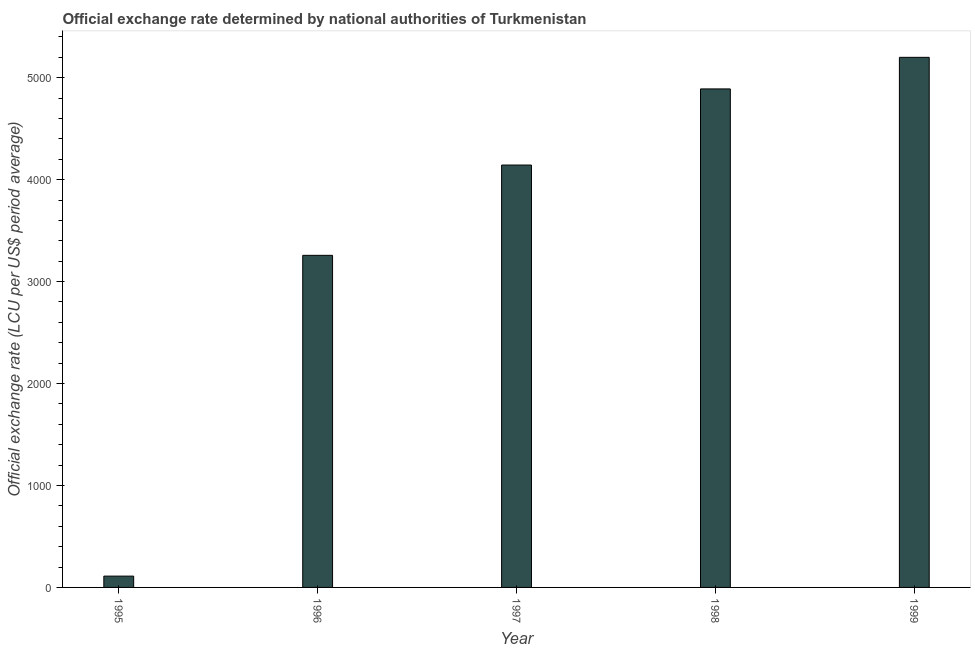Does the graph contain grids?
Offer a terse response. No. What is the title of the graph?
Ensure brevity in your answer.  Official exchange rate determined by national authorities of Turkmenistan. What is the label or title of the Y-axis?
Give a very brief answer. Official exchange rate (LCU per US$ period average). What is the official exchange rate in 1998?
Give a very brief answer. 4890.17. Across all years, what is the maximum official exchange rate?
Provide a succinct answer. 5200. Across all years, what is the minimum official exchange rate?
Your answer should be compact. 110.92. In which year was the official exchange rate maximum?
Your answer should be very brief. 1999. In which year was the official exchange rate minimum?
Offer a terse response. 1995. What is the sum of the official exchange rate?
Your response must be concise. 1.76e+04. What is the difference between the official exchange rate in 1998 and 1999?
Give a very brief answer. -309.83. What is the average official exchange rate per year?
Your response must be concise. 3520.43. What is the median official exchange rate?
Make the answer very short. 4143.42. In how many years, is the official exchange rate greater than 1800 ?
Keep it short and to the point. 4. Do a majority of the years between 1995 and 1996 (inclusive) have official exchange rate greater than 5200 ?
Offer a very short reply. No. What is the ratio of the official exchange rate in 1995 to that in 1999?
Make the answer very short. 0.02. What is the difference between the highest and the second highest official exchange rate?
Give a very brief answer. 309.83. Is the sum of the official exchange rate in 1998 and 1999 greater than the maximum official exchange rate across all years?
Your answer should be compact. Yes. What is the difference between the highest and the lowest official exchange rate?
Ensure brevity in your answer.  5089.08. In how many years, is the official exchange rate greater than the average official exchange rate taken over all years?
Make the answer very short. 3. How many years are there in the graph?
Provide a succinct answer. 5. What is the difference between two consecutive major ticks on the Y-axis?
Offer a terse response. 1000. What is the Official exchange rate (LCU per US$ period average) in 1995?
Make the answer very short. 110.92. What is the Official exchange rate (LCU per US$ period average) of 1996?
Ensure brevity in your answer.  3257.67. What is the Official exchange rate (LCU per US$ period average) of 1997?
Make the answer very short. 4143.42. What is the Official exchange rate (LCU per US$ period average) in 1998?
Ensure brevity in your answer.  4890.17. What is the Official exchange rate (LCU per US$ period average) in 1999?
Give a very brief answer. 5200. What is the difference between the Official exchange rate (LCU per US$ period average) in 1995 and 1996?
Your answer should be compact. -3146.75. What is the difference between the Official exchange rate (LCU per US$ period average) in 1995 and 1997?
Provide a short and direct response. -4032.5. What is the difference between the Official exchange rate (LCU per US$ period average) in 1995 and 1998?
Provide a succinct answer. -4779.25. What is the difference between the Official exchange rate (LCU per US$ period average) in 1995 and 1999?
Your answer should be compact. -5089.08. What is the difference between the Official exchange rate (LCU per US$ period average) in 1996 and 1997?
Ensure brevity in your answer.  -885.75. What is the difference between the Official exchange rate (LCU per US$ period average) in 1996 and 1998?
Give a very brief answer. -1632.5. What is the difference between the Official exchange rate (LCU per US$ period average) in 1996 and 1999?
Make the answer very short. -1942.33. What is the difference between the Official exchange rate (LCU per US$ period average) in 1997 and 1998?
Make the answer very short. -746.75. What is the difference between the Official exchange rate (LCU per US$ period average) in 1997 and 1999?
Offer a very short reply. -1056.58. What is the difference between the Official exchange rate (LCU per US$ period average) in 1998 and 1999?
Your answer should be compact. -309.83. What is the ratio of the Official exchange rate (LCU per US$ period average) in 1995 to that in 1996?
Offer a terse response. 0.03. What is the ratio of the Official exchange rate (LCU per US$ period average) in 1995 to that in 1997?
Provide a short and direct response. 0.03. What is the ratio of the Official exchange rate (LCU per US$ period average) in 1995 to that in 1998?
Offer a terse response. 0.02. What is the ratio of the Official exchange rate (LCU per US$ period average) in 1995 to that in 1999?
Your answer should be compact. 0.02. What is the ratio of the Official exchange rate (LCU per US$ period average) in 1996 to that in 1997?
Ensure brevity in your answer.  0.79. What is the ratio of the Official exchange rate (LCU per US$ period average) in 1996 to that in 1998?
Your answer should be very brief. 0.67. What is the ratio of the Official exchange rate (LCU per US$ period average) in 1996 to that in 1999?
Your answer should be compact. 0.63. What is the ratio of the Official exchange rate (LCU per US$ period average) in 1997 to that in 1998?
Your answer should be compact. 0.85. What is the ratio of the Official exchange rate (LCU per US$ period average) in 1997 to that in 1999?
Provide a succinct answer. 0.8. What is the ratio of the Official exchange rate (LCU per US$ period average) in 1998 to that in 1999?
Your answer should be very brief. 0.94. 